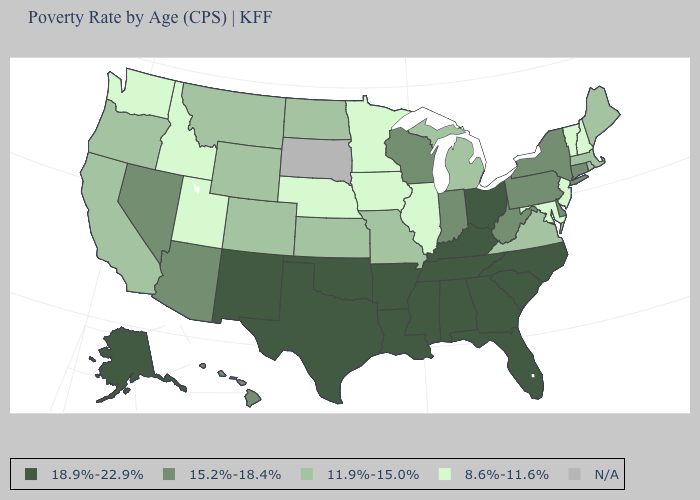What is the value of Maryland?
Write a very short answer. 8.6%-11.6%. What is the highest value in states that border South Dakota?
Concise answer only. 11.9%-15.0%. What is the value of South Dakota?
Quick response, please. N/A. What is the value of Hawaii?
Give a very brief answer. 15.2%-18.4%. Name the states that have a value in the range 15.2%-18.4%?
Write a very short answer. Arizona, Connecticut, Delaware, Hawaii, Indiana, Nevada, New York, Pennsylvania, West Virginia, Wisconsin. Is the legend a continuous bar?
Keep it brief. No. Among the states that border Michigan , does Indiana have the highest value?
Give a very brief answer. No. Does the first symbol in the legend represent the smallest category?
Give a very brief answer. No. How many symbols are there in the legend?
Keep it brief. 5. What is the value of Kentucky?
Write a very short answer. 18.9%-22.9%. What is the highest value in the USA?
Keep it brief. 18.9%-22.9%. What is the lowest value in the USA?
Keep it brief. 8.6%-11.6%. Does Tennessee have the highest value in the USA?
Quick response, please. Yes. Does Idaho have the lowest value in the USA?
Give a very brief answer. Yes. What is the value of Indiana?
Concise answer only. 15.2%-18.4%. 